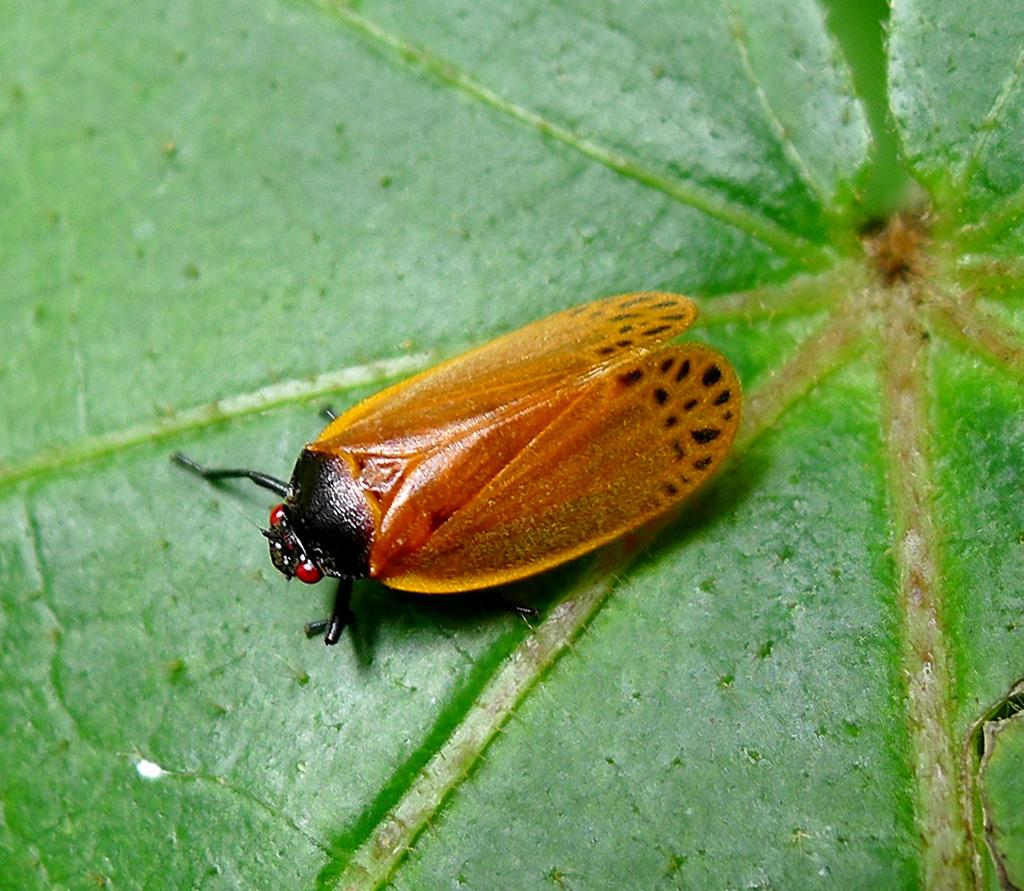What type of creature can be seen in the image? There is an insect (likely a fly) in the image. What is the insect standing on? The insect is standing on a leaf. What type of boat is visible in the image? There is no boat present in the image; it features an insect standing on a leaf. What type of eggs can be seen in the image? There are no eggs present in the image; it features an insect standing on a leaf. 